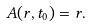Convert formula to latex. <formula><loc_0><loc_0><loc_500><loc_500>A ( r , t _ { 0 } ) = r .</formula> 